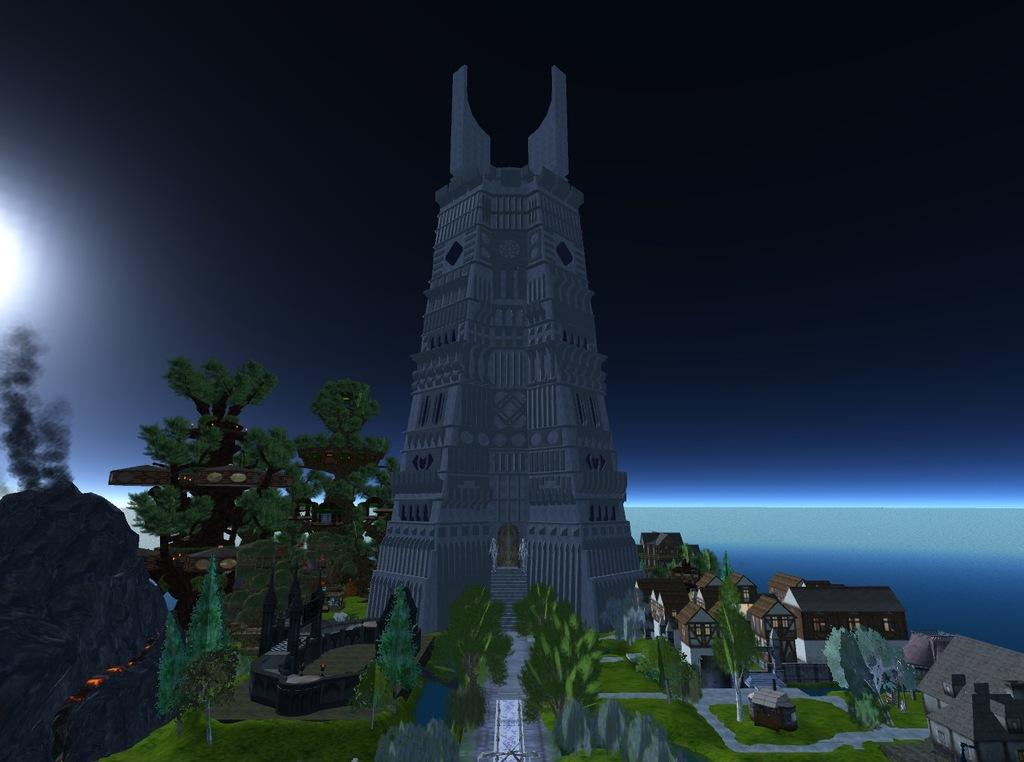What type of structures can be seen in the image? There are buildings in the image. What type of vegetation is present in the image? There are trees and grass in the image. What is visible at the top of the image? The sky is visible at the top of the image. Where is the bridge located in the image? There is no bridge present in the image. How much shade is provided by the trees in the image? The image does not provide information about the amount of shade provided by the trees. 